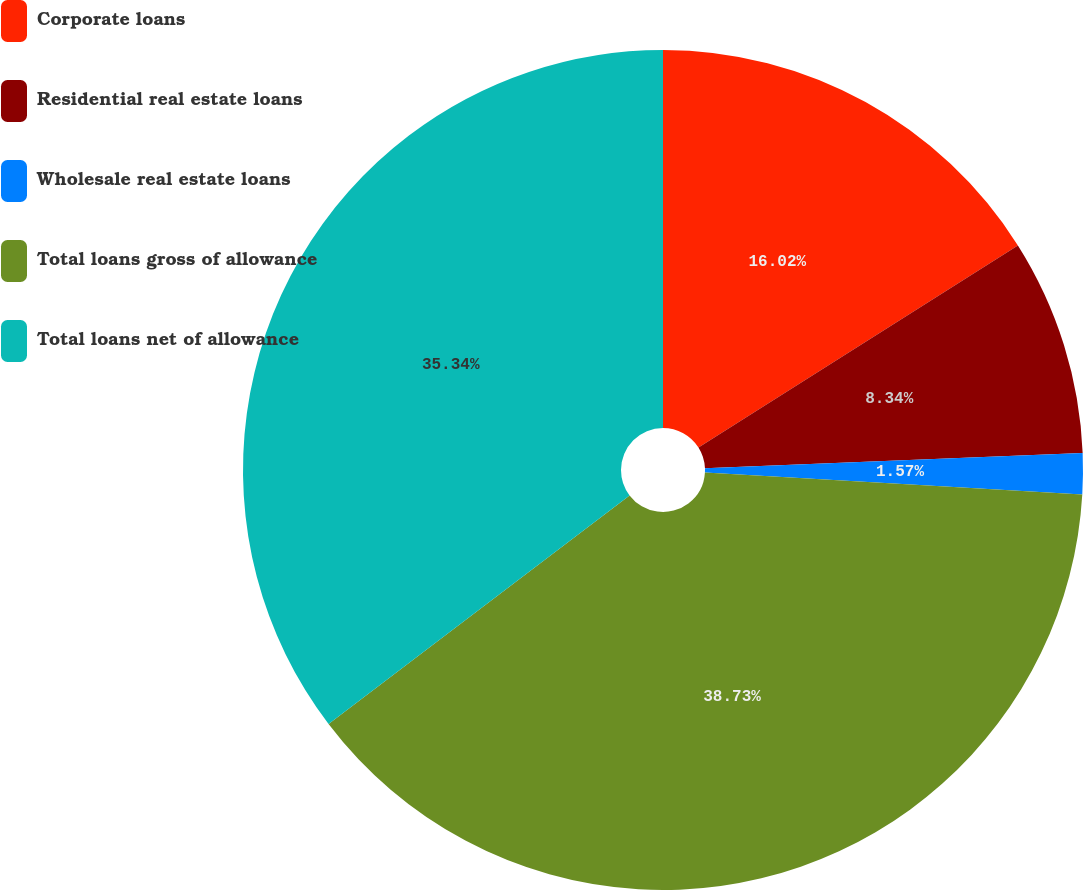<chart> <loc_0><loc_0><loc_500><loc_500><pie_chart><fcel>Corporate loans<fcel>Residential real estate loans<fcel>Wholesale real estate loans<fcel>Total loans gross of allowance<fcel>Total loans net of allowance<nl><fcel>16.02%<fcel>8.34%<fcel>1.57%<fcel>38.73%<fcel>35.34%<nl></chart> 